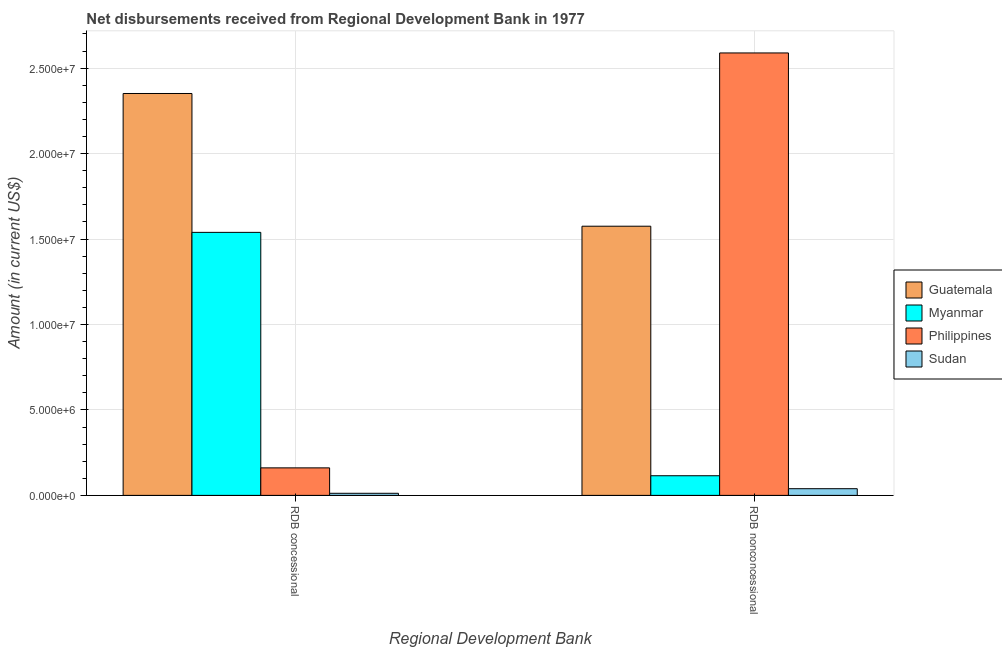How many groups of bars are there?
Offer a very short reply. 2. How many bars are there on the 2nd tick from the right?
Make the answer very short. 4. What is the label of the 1st group of bars from the left?
Give a very brief answer. RDB concessional. What is the net non concessional disbursements from rdb in Philippines?
Give a very brief answer. 2.59e+07. Across all countries, what is the maximum net concessional disbursements from rdb?
Make the answer very short. 2.35e+07. Across all countries, what is the minimum net concessional disbursements from rdb?
Provide a succinct answer. 1.23e+05. In which country was the net concessional disbursements from rdb maximum?
Give a very brief answer. Guatemala. In which country was the net non concessional disbursements from rdb minimum?
Ensure brevity in your answer.  Sudan. What is the total net non concessional disbursements from rdb in the graph?
Your response must be concise. 4.32e+07. What is the difference between the net non concessional disbursements from rdb in Philippines and that in Guatemala?
Make the answer very short. 1.01e+07. What is the difference between the net concessional disbursements from rdb in Sudan and the net non concessional disbursements from rdb in Myanmar?
Your response must be concise. -1.03e+06. What is the average net concessional disbursements from rdb per country?
Provide a succinct answer. 1.02e+07. What is the difference between the net non concessional disbursements from rdb and net concessional disbursements from rdb in Sudan?
Provide a succinct answer. 2.69e+05. What is the ratio of the net non concessional disbursements from rdb in Sudan to that in Myanmar?
Your response must be concise. 0.34. Is the net non concessional disbursements from rdb in Philippines less than that in Guatemala?
Provide a succinct answer. No. In how many countries, is the net concessional disbursements from rdb greater than the average net concessional disbursements from rdb taken over all countries?
Offer a terse response. 2. What does the 3rd bar from the right in RDB nonconcessional represents?
Offer a terse response. Myanmar. How many bars are there?
Make the answer very short. 8. What is the difference between two consecutive major ticks on the Y-axis?
Keep it short and to the point. 5.00e+06. Are the values on the major ticks of Y-axis written in scientific E-notation?
Provide a short and direct response. Yes. Does the graph contain any zero values?
Provide a short and direct response. No. Where does the legend appear in the graph?
Ensure brevity in your answer.  Center right. How many legend labels are there?
Offer a terse response. 4. What is the title of the graph?
Ensure brevity in your answer.  Net disbursements received from Regional Development Bank in 1977. Does "Eritrea" appear as one of the legend labels in the graph?
Give a very brief answer. No. What is the label or title of the X-axis?
Your answer should be very brief. Regional Development Bank. What is the label or title of the Y-axis?
Your answer should be compact. Amount (in current US$). What is the Amount (in current US$) in Guatemala in RDB concessional?
Provide a succinct answer. 2.35e+07. What is the Amount (in current US$) of Myanmar in RDB concessional?
Your answer should be compact. 1.54e+07. What is the Amount (in current US$) of Philippines in RDB concessional?
Your answer should be compact. 1.61e+06. What is the Amount (in current US$) of Sudan in RDB concessional?
Keep it short and to the point. 1.23e+05. What is the Amount (in current US$) of Guatemala in RDB nonconcessional?
Provide a succinct answer. 1.58e+07. What is the Amount (in current US$) of Myanmar in RDB nonconcessional?
Your answer should be compact. 1.15e+06. What is the Amount (in current US$) in Philippines in RDB nonconcessional?
Your answer should be very brief. 2.59e+07. What is the Amount (in current US$) in Sudan in RDB nonconcessional?
Your answer should be very brief. 3.92e+05. Across all Regional Development Bank, what is the maximum Amount (in current US$) in Guatemala?
Offer a terse response. 2.35e+07. Across all Regional Development Bank, what is the maximum Amount (in current US$) of Myanmar?
Give a very brief answer. 1.54e+07. Across all Regional Development Bank, what is the maximum Amount (in current US$) of Philippines?
Provide a short and direct response. 2.59e+07. Across all Regional Development Bank, what is the maximum Amount (in current US$) of Sudan?
Ensure brevity in your answer.  3.92e+05. Across all Regional Development Bank, what is the minimum Amount (in current US$) in Guatemala?
Make the answer very short. 1.58e+07. Across all Regional Development Bank, what is the minimum Amount (in current US$) of Myanmar?
Give a very brief answer. 1.15e+06. Across all Regional Development Bank, what is the minimum Amount (in current US$) in Philippines?
Provide a succinct answer. 1.61e+06. Across all Regional Development Bank, what is the minimum Amount (in current US$) of Sudan?
Provide a succinct answer. 1.23e+05. What is the total Amount (in current US$) in Guatemala in the graph?
Provide a short and direct response. 3.93e+07. What is the total Amount (in current US$) of Myanmar in the graph?
Provide a succinct answer. 1.65e+07. What is the total Amount (in current US$) in Philippines in the graph?
Provide a succinct answer. 2.75e+07. What is the total Amount (in current US$) in Sudan in the graph?
Give a very brief answer. 5.15e+05. What is the difference between the Amount (in current US$) in Guatemala in RDB concessional and that in RDB nonconcessional?
Provide a short and direct response. 7.77e+06. What is the difference between the Amount (in current US$) of Myanmar in RDB concessional and that in RDB nonconcessional?
Offer a terse response. 1.42e+07. What is the difference between the Amount (in current US$) in Philippines in RDB concessional and that in RDB nonconcessional?
Your answer should be compact. -2.43e+07. What is the difference between the Amount (in current US$) of Sudan in RDB concessional and that in RDB nonconcessional?
Keep it short and to the point. -2.69e+05. What is the difference between the Amount (in current US$) of Guatemala in RDB concessional and the Amount (in current US$) of Myanmar in RDB nonconcessional?
Your answer should be compact. 2.24e+07. What is the difference between the Amount (in current US$) of Guatemala in RDB concessional and the Amount (in current US$) of Philippines in RDB nonconcessional?
Give a very brief answer. -2.37e+06. What is the difference between the Amount (in current US$) in Guatemala in RDB concessional and the Amount (in current US$) in Sudan in RDB nonconcessional?
Your answer should be compact. 2.31e+07. What is the difference between the Amount (in current US$) in Myanmar in RDB concessional and the Amount (in current US$) in Philippines in RDB nonconcessional?
Your response must be concise. -1.05e+07. What is the difference between the Amount (in current US$) in Myanmar in RDB concessional and the Amount (in current US$) in Sudan in RDB nonconcessional?
Make the answer very short. 1.50e+07. What is the difference between the Amount (in current US$) in Philippines in RDB concessional and the Amount (in current US$) in Sudan in RDB nonconcessional?
Offer a very short reply. 1.22e+06. What is the average Amount (in current US$) of Guatemala per Regional Development Bank?
Offer a terse response. 1.96e+07. What is the average Amount (in current US$) in Myanmar per Regional Development Bank?
Keep it short and to the point. 8.27e+06. What is the average Amount (in current US$) of Philippines per Regional Development Bank?
Provide a succinct answer. 1.38e+07. What is the average Amount (in current US$) in Sudan per Regional Development Bank?
Your response must be concise. 2.58e+05. What is the difference between the Amount (in current US$) of Guatemala and Amount (in current US$) of Myanmar in RDB concessional?
Your answer should be very brief. 8.13e+06. What is the difference between the Amount (in current US$) in Guatemala and Amount (in current US$) in Philippines in RDB concessional?
Ensure brevity in your answer.  2.19e+07. What is the difference between the Amount (in current US$) in Guatemala and Amount (in current US$) in Sudan in RDB concessional?
Your answer should be compact. 2.34e+07. What is the difference between the Amount (in current US$) of Myanmar and Amount (in current US$) of Philippines in RDB concessional?
Ensure brevity in your answer.  1.38e+07. What is the difference between the Amount (in current US$) of Myanmar and Amount (in current US$) of Sudan in RDB concessional?
Offer a terse response. 1.53e+07. What is the difference between the Amount (in current US$) in Philippines and Amount (in current US$) in Sudan in RDB concessional?
Provide a succinct answer. 1.49e+06. What is the difference between the Amount (in current US$) in Guatemala and Amount (in current US$) in Myanmar in RDB nonconcessional?
Ensure brevity in your answer.  1.46e+07. What is the difference between the Amount (in current US$) of Guatemala and Amount (in current US$) of Philippines in RDB nonconcessional?
Your answer should be very brief. -1.01e+07. What is the difference between the Amount (in current US$) in Guatemala and Amount (in current US$) in Sudan in RDB nonconcessional?
Provide a short and direct response. 1.54e+07. What is the difference between the Amount (in current US$) of Myanmar and Amount (in current US$) of Philippines in RDB nonconcessional?
Offer a very short reply. -2.47e+07. What is the difference between the Amount (in current US$) of Myanmar and Amount (in current US$) of Sudan in RDB nonconcessional?
Ensure brevity in your answer.  7.58e+05. What is the difference between the Amount (in current US$) in Philippines and Amount (in current US$) in Sudan in RDB nonconcessional?
Ensure brevity in your answer.  2.55e+07. What is the ratio of the Amount (in current US$) in Guatemala in RDB concessional to that in RDB nonconcessional?
Keep it short and to the point. 1.49. What is the ratio of the Amount (in current US$) of Myanmar in RDB concessional to that in RDB nonconcessional?
Provide a short and direct response. 13.38. What is the ratio of the Amount (in current US$) in Philippines in RDB concessional to that in RDB nonconcessional?
Ensure brevity in your answer.  0.06. What is the ratio of the Amount (in current US$) of Sudan in RDB concessional to that in RDB nonconcessional?
Your response must be concise. 0.31. What is the difference between the highest and the second highest Amount (in current US$) in Guatemala?
Provide a short and direct response. 7.77e+06. What is the difference between the highest and the second highest Amount (in current US$) in Myanmar?
Provide a succinct answer. 1.42e+07. What is the difference between the highest and the second highest Amount (in current US$) of Philippines?
Offer a very short reply. 2.43e+07. What is the difference between the highest and the second highest Amount (in current US$) in Sudan?
Keep it short and to the point. 2.69e+05. What is the difference between the highest and the lowest Amount (in current US$) in Guatemala?
Ensure brevity in your answer.  7.77e+06. What is the difference between the highest and the lowest Amount (in current US$) of Myanmar?
Provide a short and direct response. 1.42e+07. What is the difference between the highest and the lowest Amount (in current US$) of Philippines?
Provide a short and direct response. 2.43e+07. What is the difference between the highest and the lowest Amount (in current US$) of Sudan?
Offer a very short reply. 2.69e+05. 